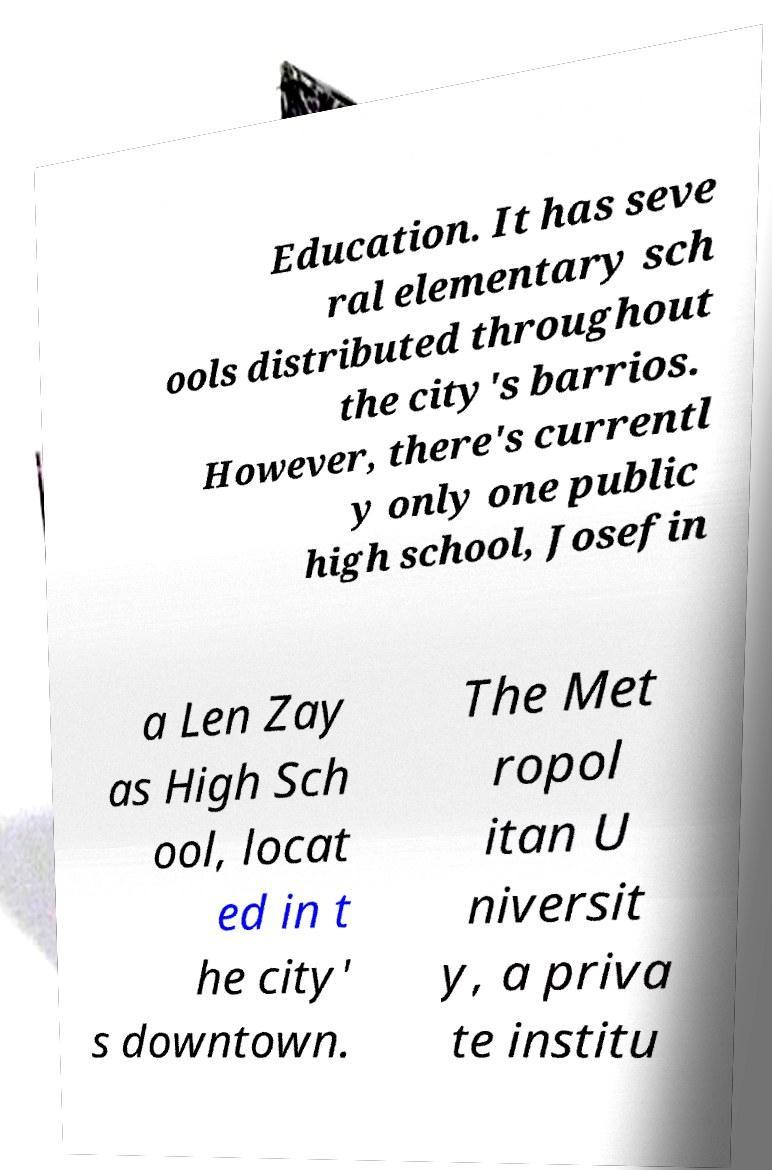Could you assist in decoding the text presented in this image and type it out clearly? Education. It has seve ral elementary sch ools distributed throughout the city's barrios. However, there's currentl y only one public high school, Josefin a Len Zay as High Sch ool, locat ed in t he city' s downtown. The Met ropol itan U niversit y, a priva te institu 